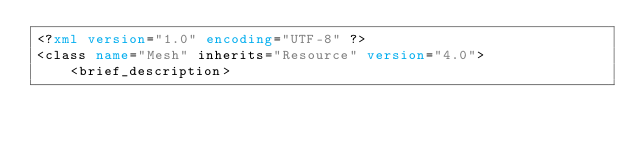Convert code to text. <code><loc_0><loc_0><loc_500><loc_500><_XML_><?xml version="1.0" encoding="UTF-8" ?>
<class name="Mesh" inherits="Resource" version="4.0">
	<brief_description></code> 